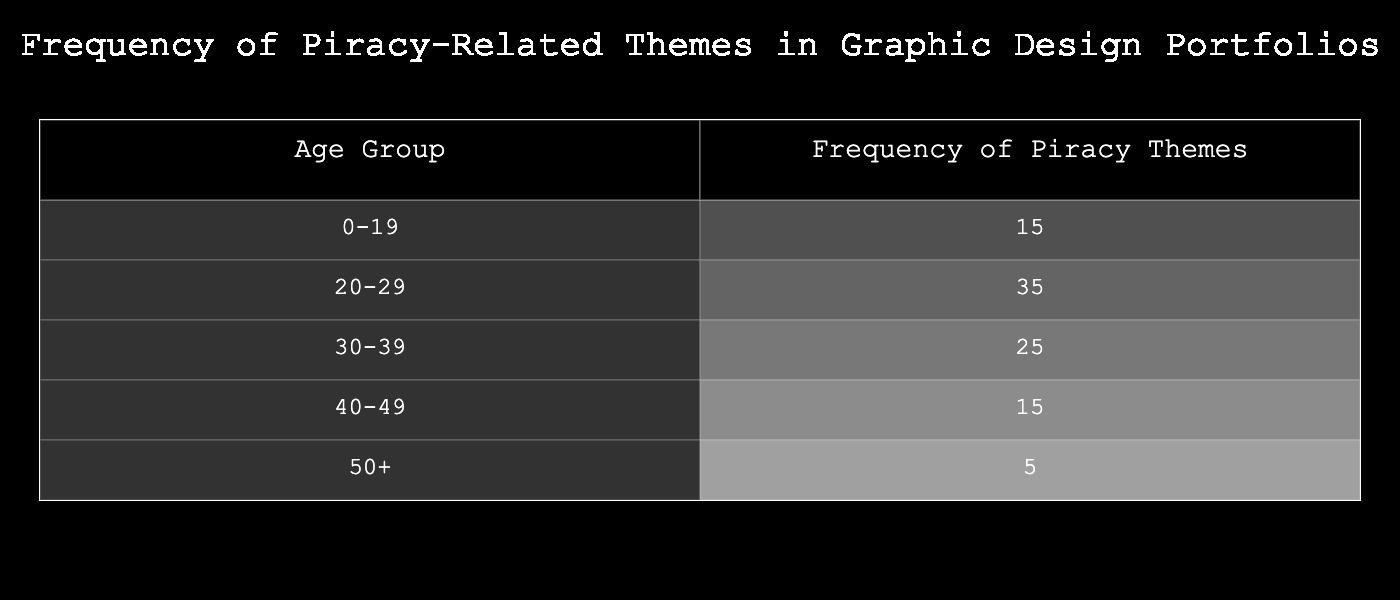What is the frequency of piracy themes in the 20-29 age group? From the table, the frequency listed under the 20-29 age group is directly stated as 35.
Answer: 35 Which age group has the lowest frequency of piracy-related themes? In the table, the age group 50+ has the lowest frequency listed, which is 5.
Answer: 50+ What is the total frequency of piracy themes across all age groups? By summing up the values for each age group: 15 + 35 + 25 + 15 + 5 = 95.
Answer: 95 What is the average frequency of piracy themes in the age group 30-39? The frequency for the 30-39 age group is 25, which is a single value, so the average is also 25.
Answer: 25 Does the frequency of piracy themes increase with age? No, the table shows that the frequency does not consistently increase with age; it peaks in the 20-29 group and decreases afterward.
Answer: No What age group has more than 20 frequencies? The age groups 20-29 (35) and 30-39 (25) both have frequencies greater than 20, while the others do not.
Answer: 20-29 and 30-39 What is the difference in frequency of piracy themes between the 20-29 age group and the 50+ age group? The frequency for 20-29 is 35 and for 50+ is 5. Therefore, the difference is 35 - 5 = 30.
Answer: 30 What percentage of the total frequency does the 40-49 age group represent? The frequency for the 40-49 age group is 15, and the total frequency is 95. Therefore, (15/95) * 100 = 15.79%.
Answer: 15.79% Which age group has a frequency of piracy themes that is less than 20? The age group 50+ has a frequency of 5, which is less than 20. The 40-49 group also has a frequency of 15, which is less than 20.
Answer: 50+ and 40-49 